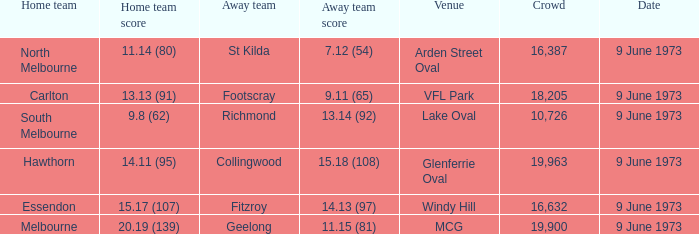Where did Fitzroy play as the away team? Windy Hill. Can you give me this table as a dict? {'header': ['Home team', 'Home team score', 'Away team', 'Away team score', 'Venue', 'Crowd', 'Date'], 'rows': [['North Melbourne', '11.14 (80)', 'St Kilda', '7.12 (54)', 'Arden Street Oval', '16,387', '9 June 1973'], ['Carlton', '13.13 (91)', 'Footscray', '9.11 (65)', 'VFL Park', '18,205', '9 June 1973'], ['South Melbourne', '9.8 (62)', 'Richmond', '13.14 (92)', 'Lake Oval', '10,726', '9 June 1973'], ['Hawthorn', '14.11 (95)', 'Collingwood', '15.18 (108)', 'Glenferrie Oval', '19,963', '9 June 1973'], ['Essendon', '15.17 (107)', 'Fitzroy', '14.13 (97)', 'Windy Hill', '16,632', '9 June 1973'], ['Melbourne', '20.19 (139)', 'Geelong', '11.15 (81)', 'MCG', '19,900', '9 June 1973']]} 